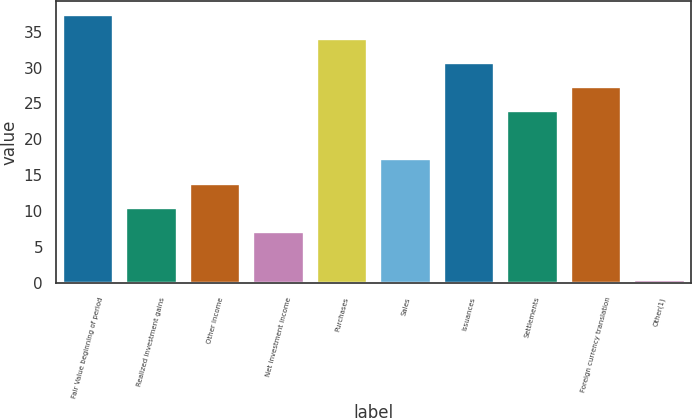Convert chart to OTSL. <chart><loc_0><loc_0><loc_500><loc_500><bar_chart><fcel>Fair Value beginning of period<fcel>Realized investment gains<fcel>Other income<fcel>Net investment income<fcel>Purchases<fcel>Sales<fcel>Issuances<fcel>Settlements<fcel>Foreign currency translation<fcel>Other(1)<nl><fcel>37.37<fcel>10.49<fcel>13.85<fcel>7.13<fcel>34.01<fcel>17.21<fcel>30.65<fcel>23.93<fcel>27.29<fcel>0.41<nl></chart> 